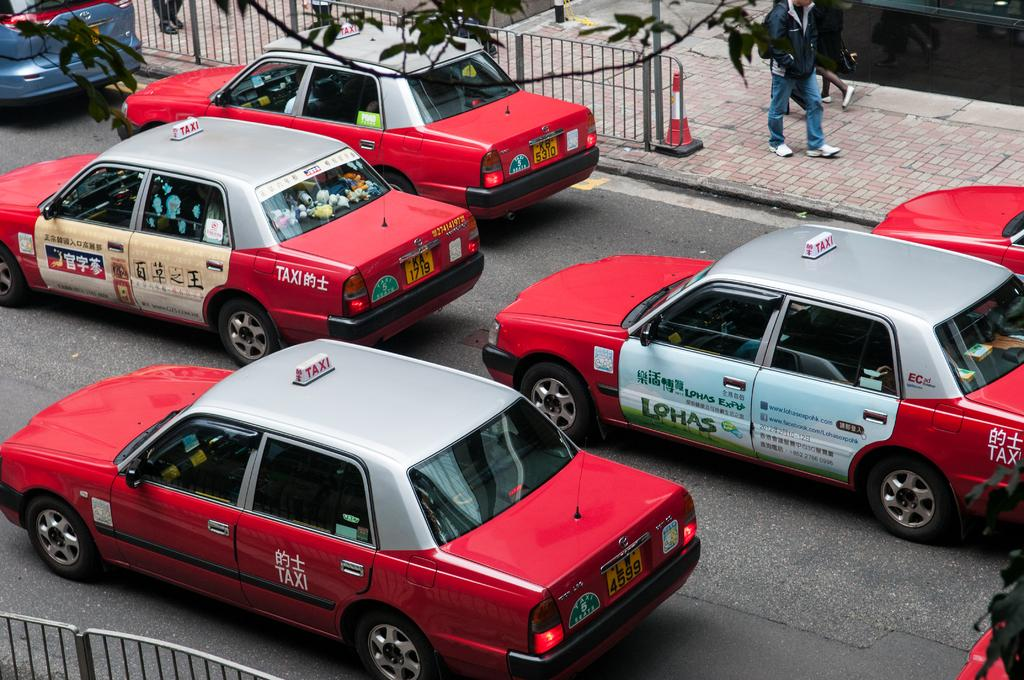<image>
Offer a succinct explanation of the picture presented. a red car has Lohas in green letters on the driver's door. 